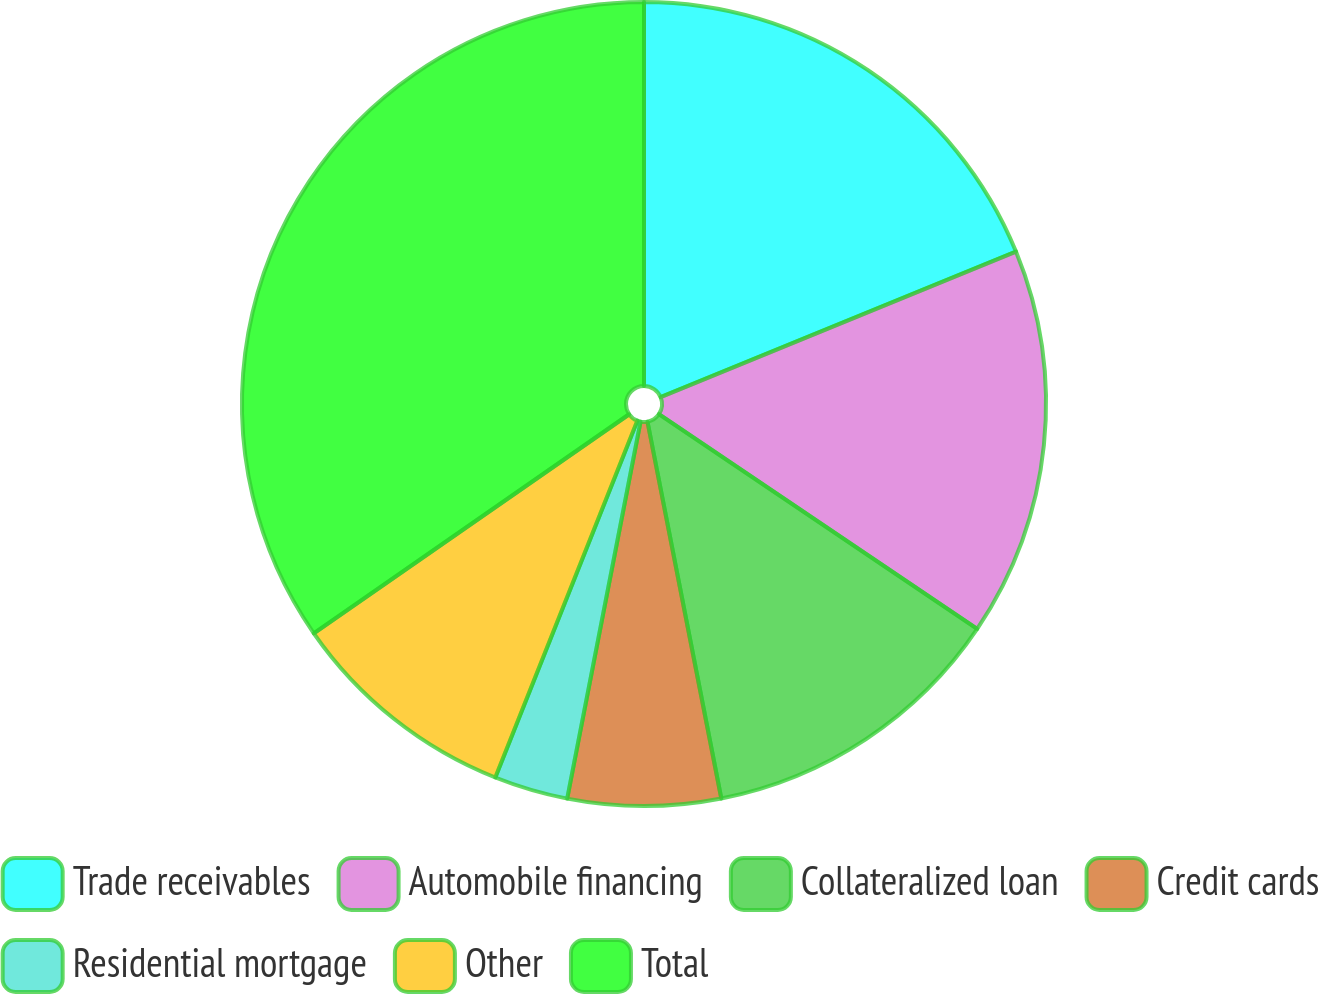Convert chart. <chart><loc_0><loc_0><loc_500><loc_500><pie_chart><fcel>Trade receivables<fcel>Automobile financing<fcel>Collateralized loan<fcel>Credit cards<fcel>Residential mortgage<fcel>Other<fcel>Total<nl><fcel>18.81%<fcel>15.64%<fcel>12.47%<fcel>6.14%<fcel>2.97%<fcel>9.31%<fcel>34.66%<nl></chart> 